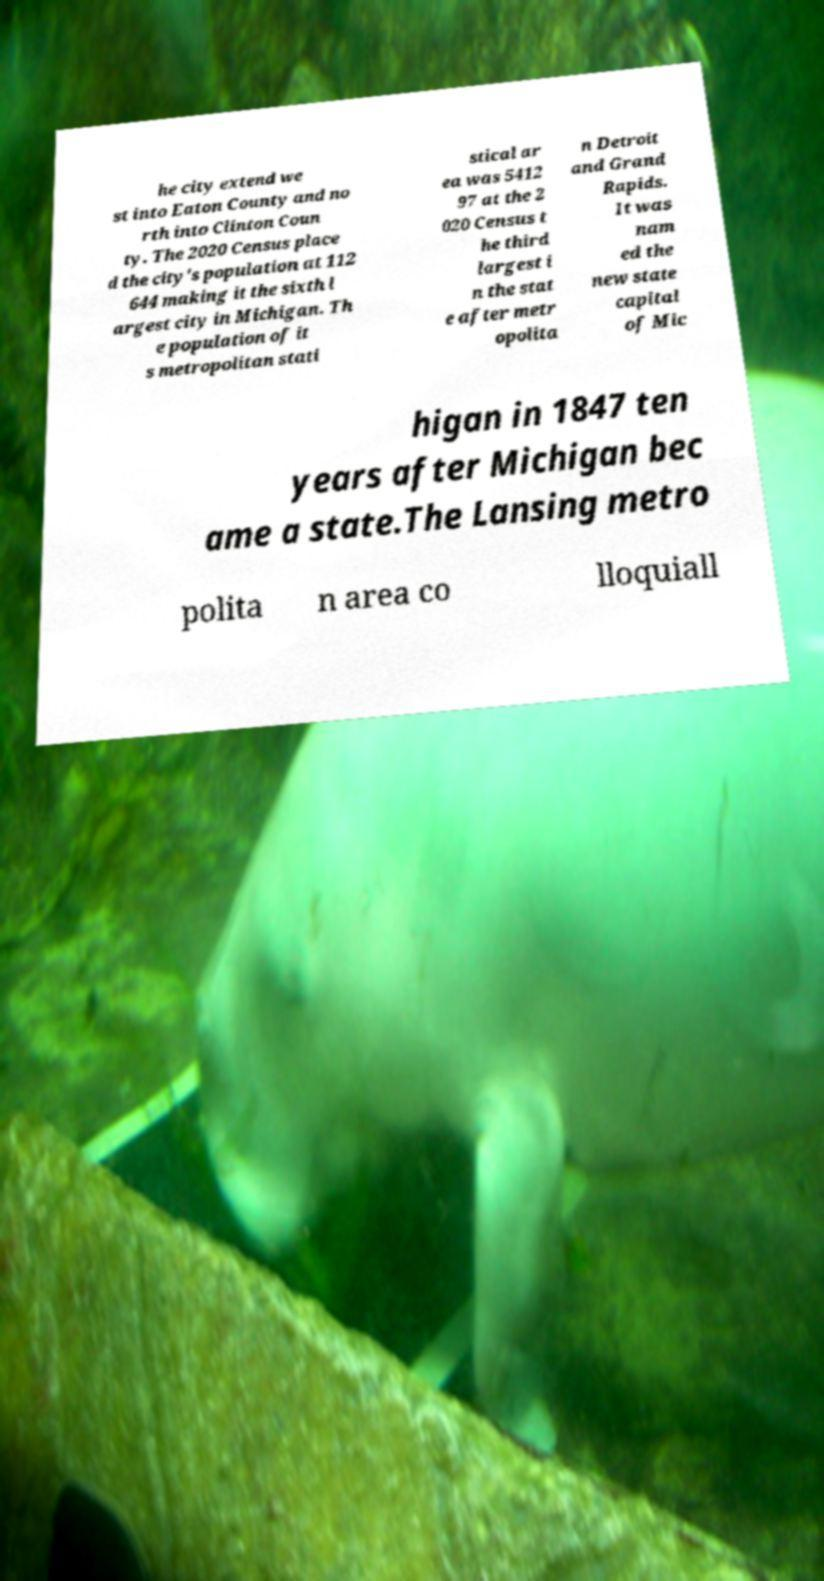Could you extract and type out the text from this image? he city extend we st into Eaton County and no rth into Clinton Coun ty. The 2020 Census place d the city's population at 112 644 making it the sixth l argest city in Michigan. Th e population of it s metropolitan stati stical ar ea was 5412 97 at the 2 020 Census t he third largest i n the stat e after metr opolita n Detroit and Grand Rapids. It was nam ed the new state capital of Mic higan in 1847 ten years after Michigan bec ame a state.The Lansing metro polita n area co lloquiall 